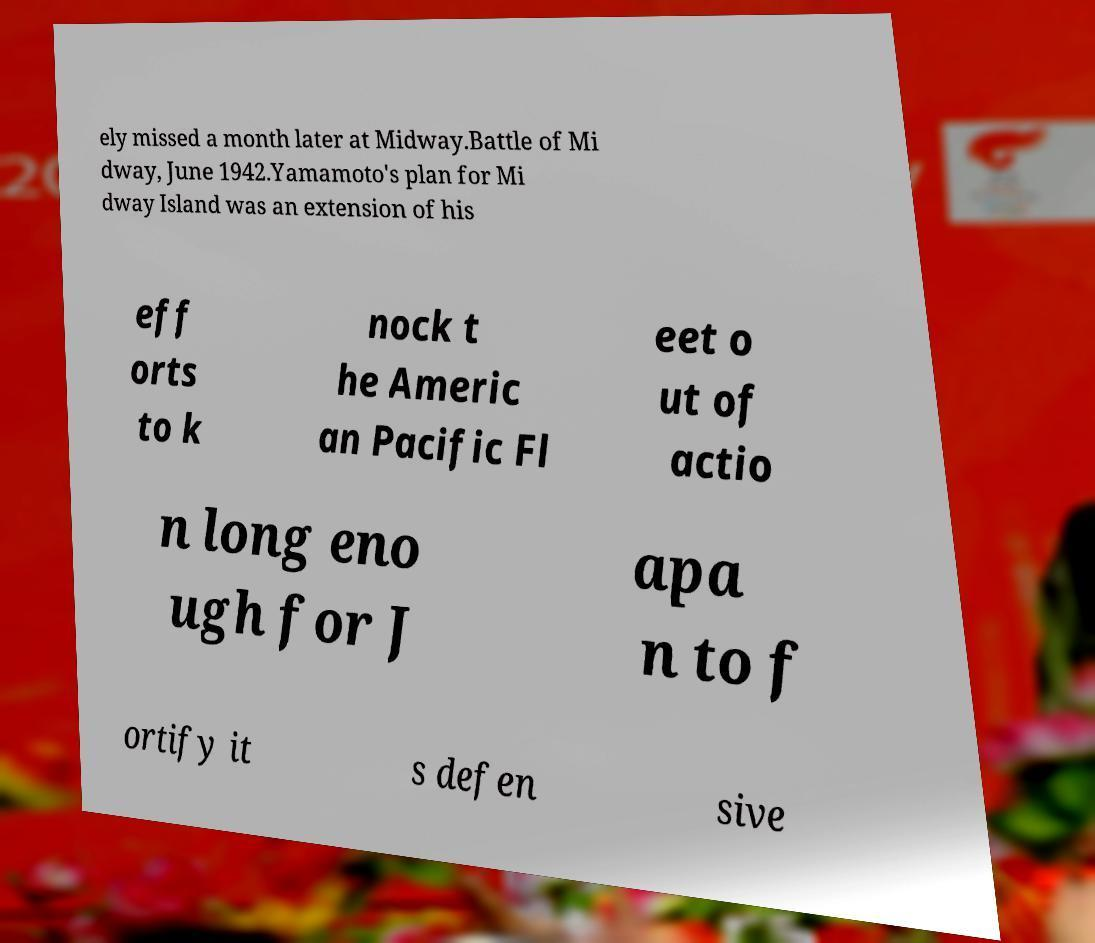Can you read and provide the text displayed in the image?This photo seems to have some interesting text. Can you extract and type it out for me? ely missed a month later at Midway.Battle of Mi dway, June 1942.Yamamoto's plan for Mi dway Island was an extension of his eff orts to k nock t he Americ an Pacific Fl eet o ut of actio n long eno ugh for J apa n to f ortify it s defen sive 